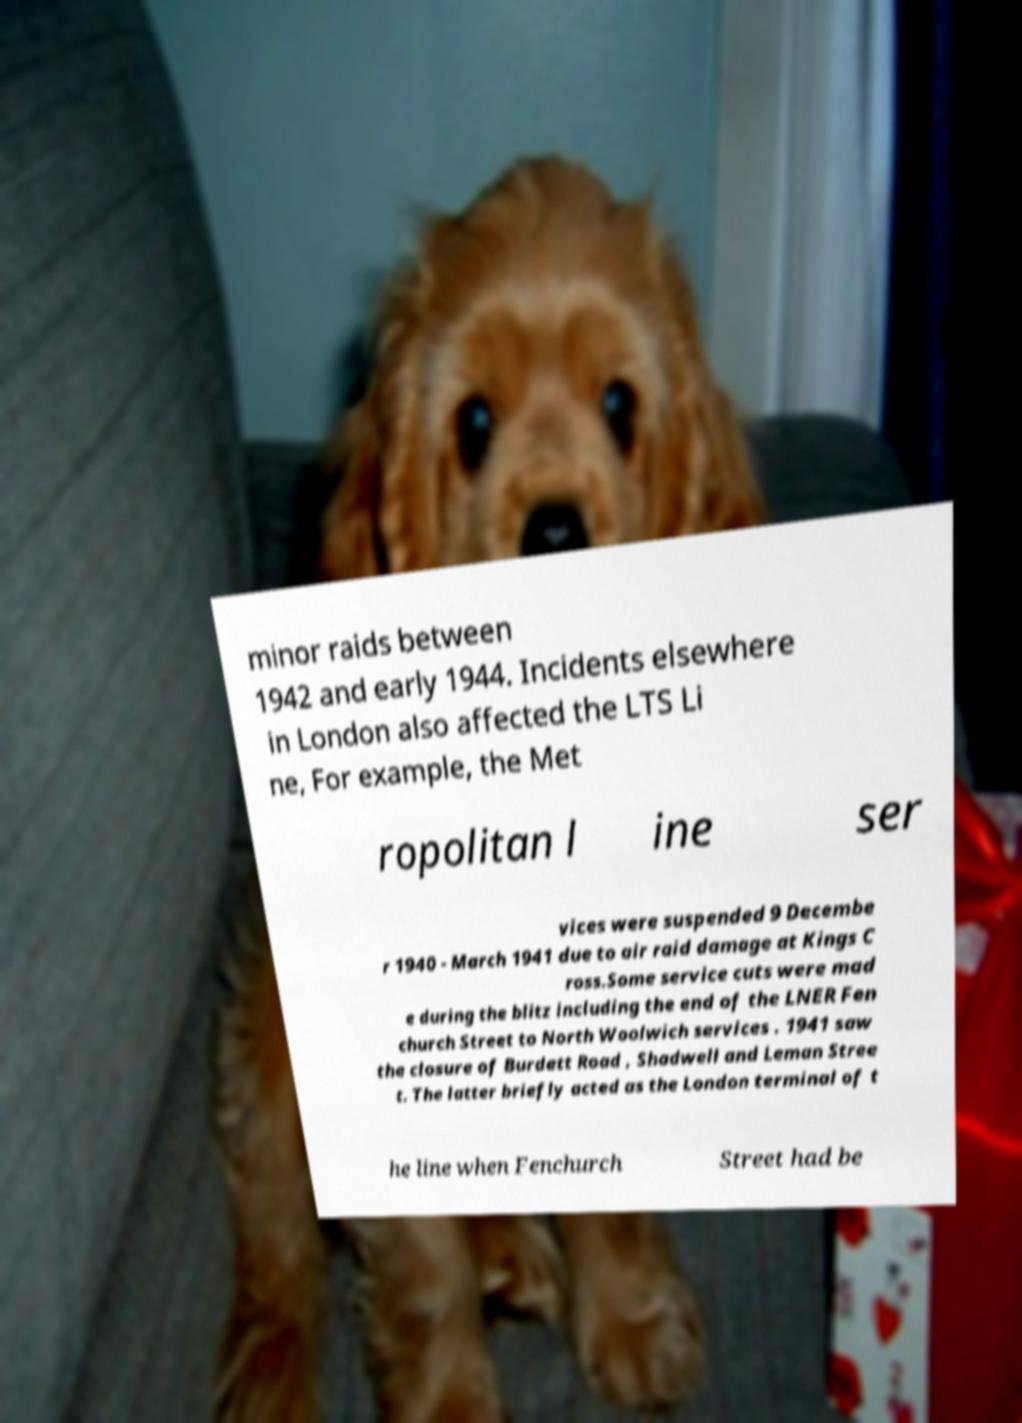For documentation purposes, I need the text within this image transcribed. Could you provide that? minor raids between 1942 and early 1944. Incidents elsewhere in London also affected the LTS Li ne, For example, the Met ropolitan l ine ser vices were suspended 9 Decembe r 1940 - March 1941 due to air raid damage at Kings C ross.Some service cuts were mad e during the blitz including the end of the LNER Fen church Street to North Woolwich services . 1941 saw the closure of Burdett Road , Shadwell and Leman Stree t. The latter briefly acted as the London terminal of t he line when Fenchurch Street had be 